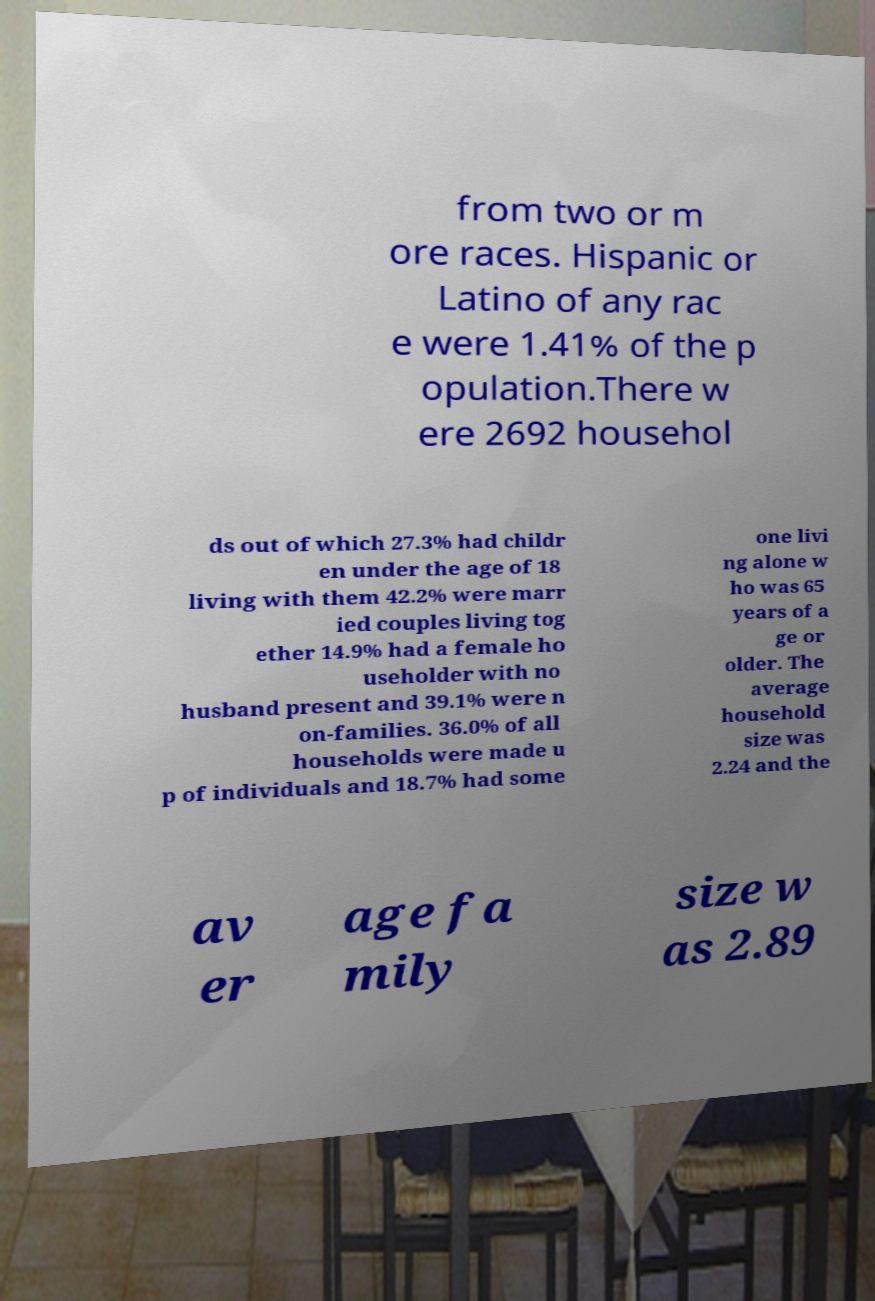There's text embedded in this image that I need extracted. Can you transcribe it verbatim? from two or m ore races. Hispanic or Latino of any rac e were 1.41% of the p opulation.There w ere 2692 househol ds out of which 27.3% had childr en under the age of 18 living with them 42.2% were marr ied couples living tog ether 14.9% had a female ho useholder with no husband present and 39.1% were n on-families. 36.0% of all households were made u p of individuals and 18.7% had some one livi ng alone w ho was 65 years of a ge or older. The average household size was 2.24 and the av er age fa mily size w as 2.89 